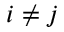<formula> <loc_0><loc_0><loc_500><loc_500>i \neq j</formula> 